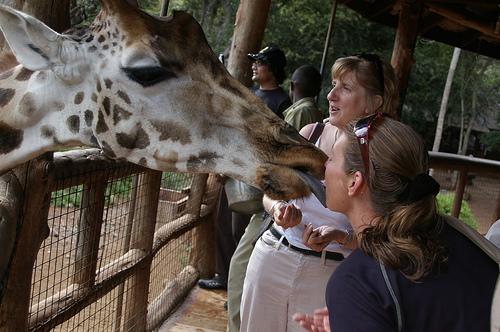How many people are there?
Be succinct. 4. What is on the woman's head?
Be succinct. Sunglasses. What color is the woman's purse?
Give a very brief answer. Black. Is this giraffe curious?
Give a very brief answer. Yes. Is it possible for the giraffe to impregnate the woman?
Write a very short answer. No. What is the girl feeding the giraffe?
Give a very brief answer. Her mouth. How many wood polls are in the back?
Write a very short answer. 2. What is the woman doing with the giraffe?
Short answer required. Kissing. What is the lady doing?
Write a very short answer. Kissing giraffe. 